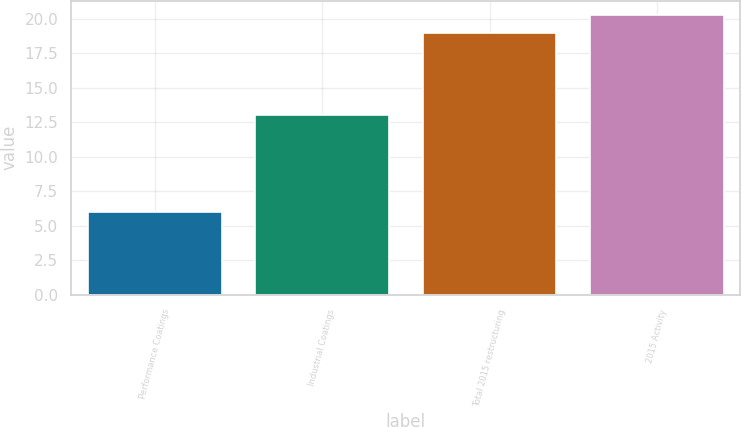<chart> <loc_0><loc_0><loc_500><loc_500><bar_chart><fcel>Performance Coatings<fcel>Industrial Coatings<fcel>Total 2015 restructuring<fcel>2015 Activity<nl><fcel>6<fcel>13<fcel>19<fcel>20.3<nl></chart> 